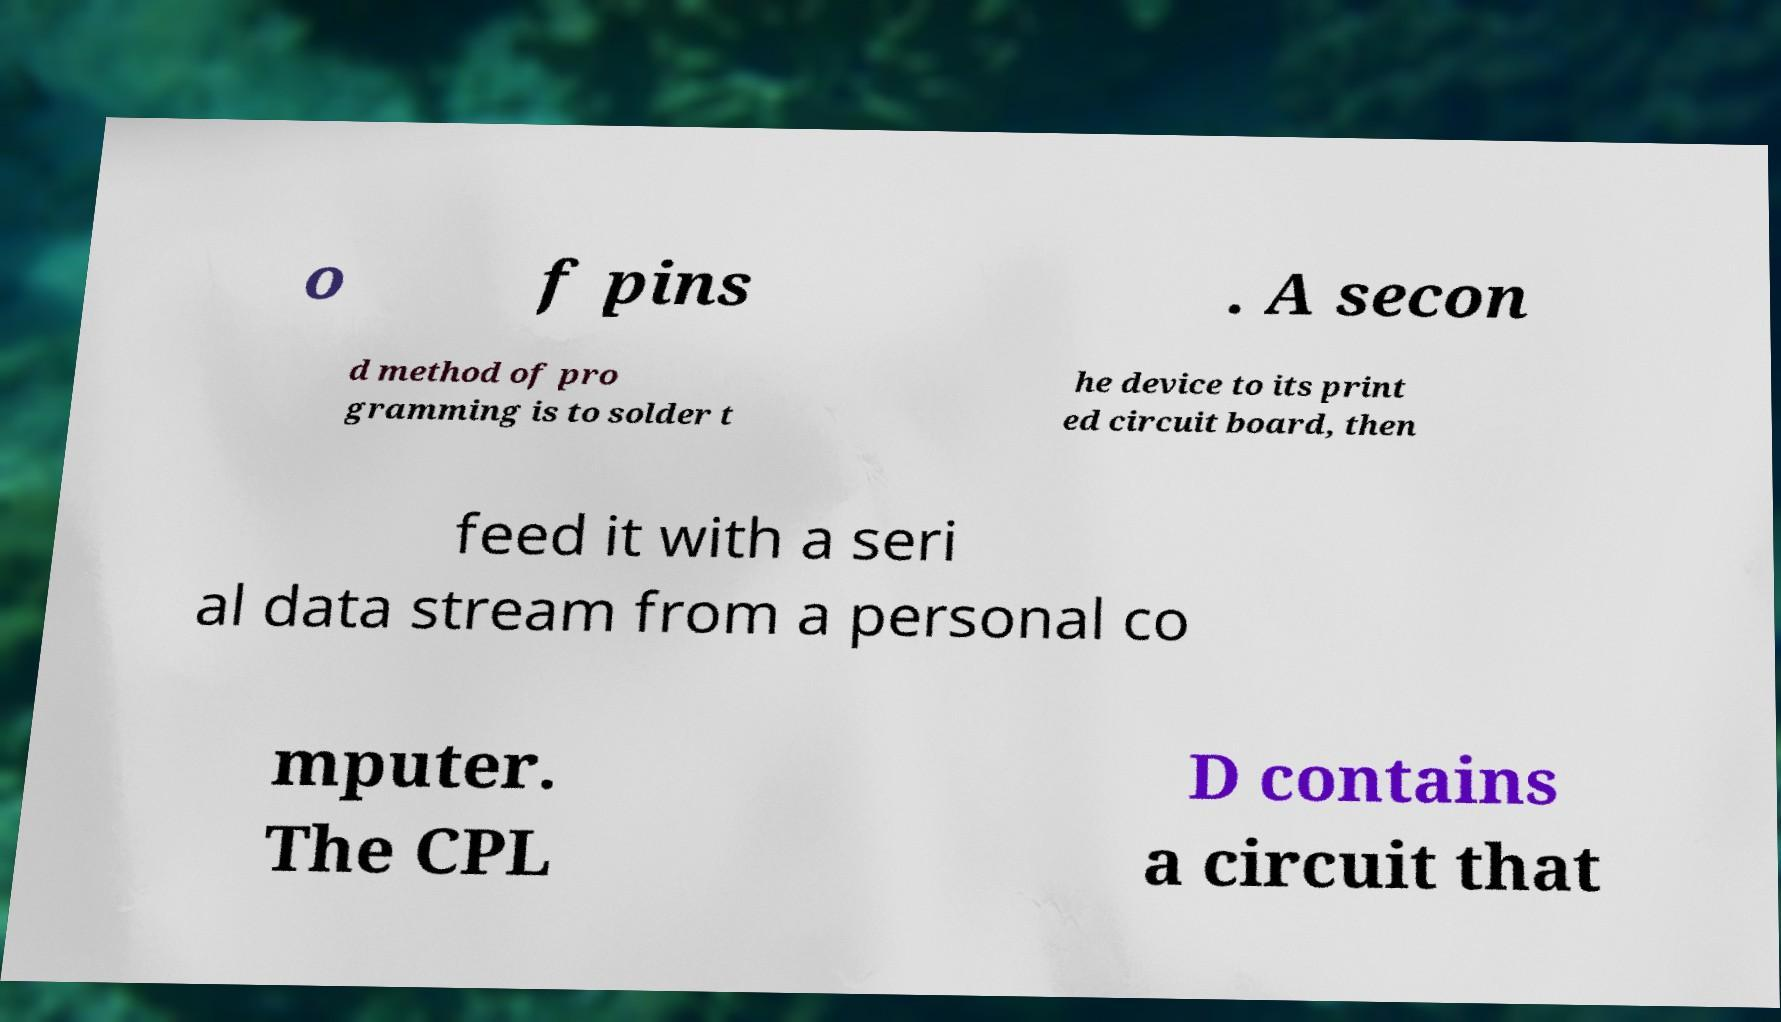What messages or text are displayed in this image? I need them in a readable, typed format. o f pins . A secon d method of pro gramming is to solder t he device to its print ed circuit board, then feed it with a seri al data stream from a personal co mputer. The CPL D contains a circuit that 